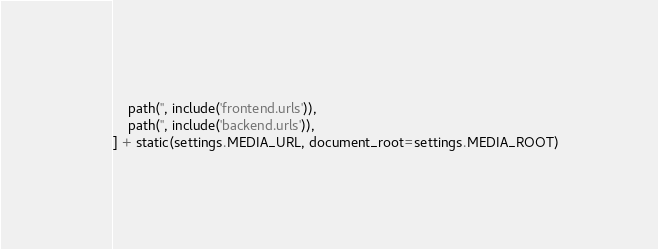<code> <loc_0><loc_0><loc_500><loc_500><_Python_>    path('', include('frontend.urls')),
    path('', include('backend.urls')),
] + static(settings.MEDIA_URL, document_root=settings.MEDIA_ROOT)
</code> 